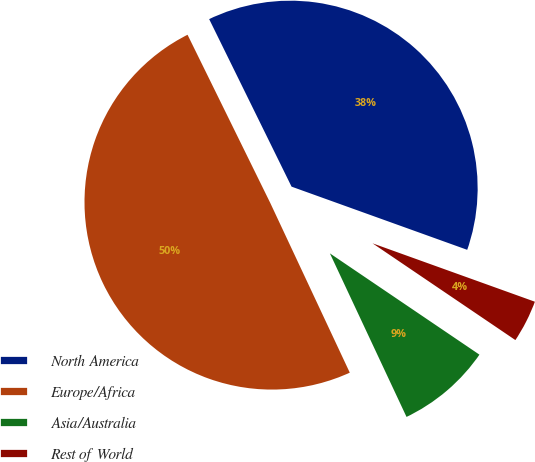Convert chart to OTSL. <chart><loc_0><loc_0><loc_500><loc_500><pie_chart><fcel>North America<fcel>Europe/Africa<fcel>Asia/Australia<fcel>Rest of World<nl><fcel>37.77%<fcel>49.7%<fcel>8.55%<fcel>3.98%<nl></chart> 